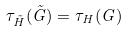Convert formula to latex. <formula><loc_0><loc_0><loc_500><loc_500>\tau _ { \tilde { H } } ( \tilde { G } ) = \tau _ { H } ( G )</formula> 